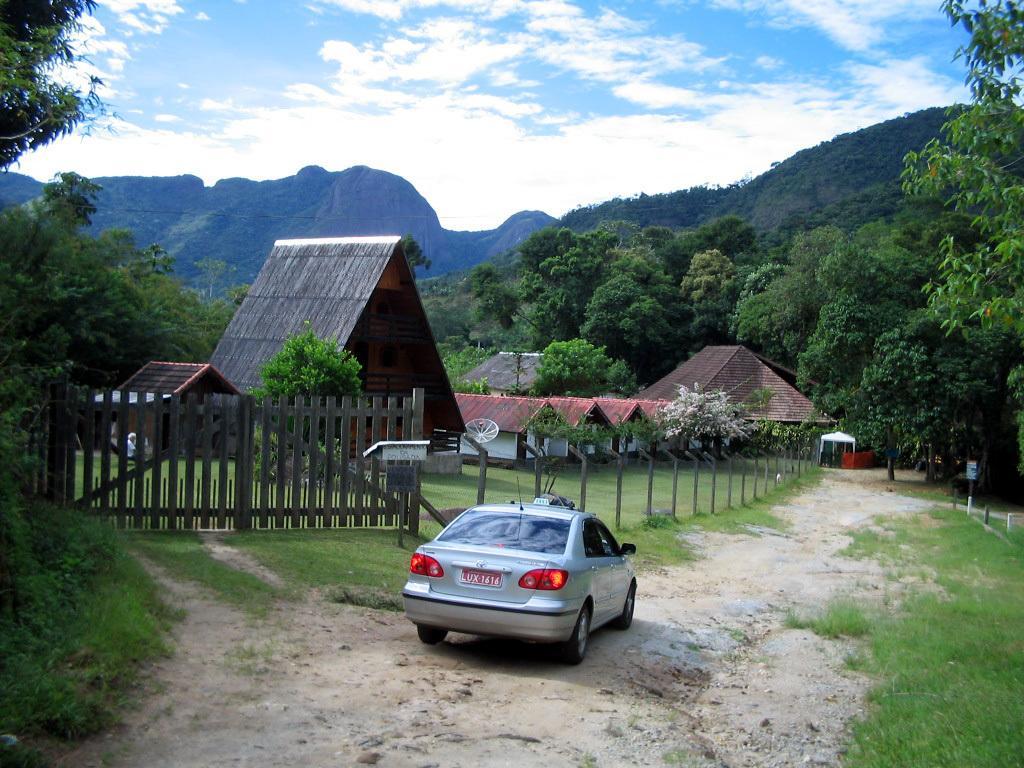How would you summarize this image in a sentence or two? In this picture I can see a vehicle on the road, there is grass, fence, there are houses, trees, hills, and in the background there is sky. 